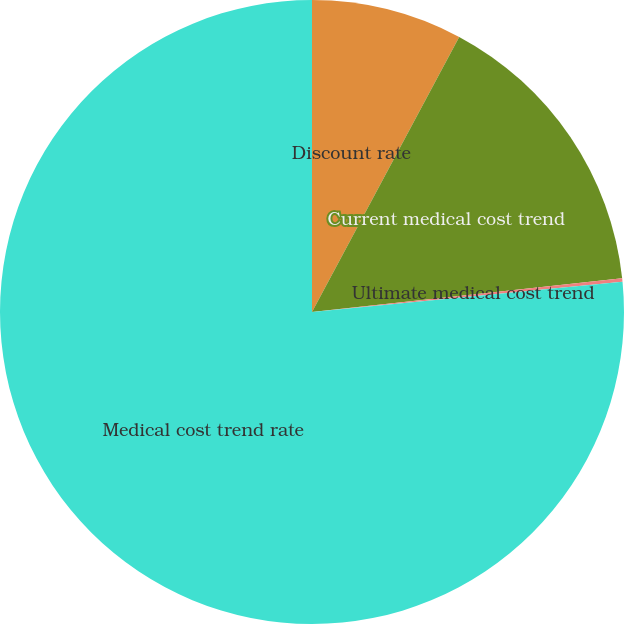<chart> <loc_0><loc_0><loc_500><loc_500><pie_chart><fcel>Discount rate<fcel>Current medical cost trend<fcel>Ultimate medical cost trend<fcel>Medical cost trend rate<nl><fcel>7.82%<fcel>15.45%<fcel>0.18%<fcel>76.55%<nl></chart> 